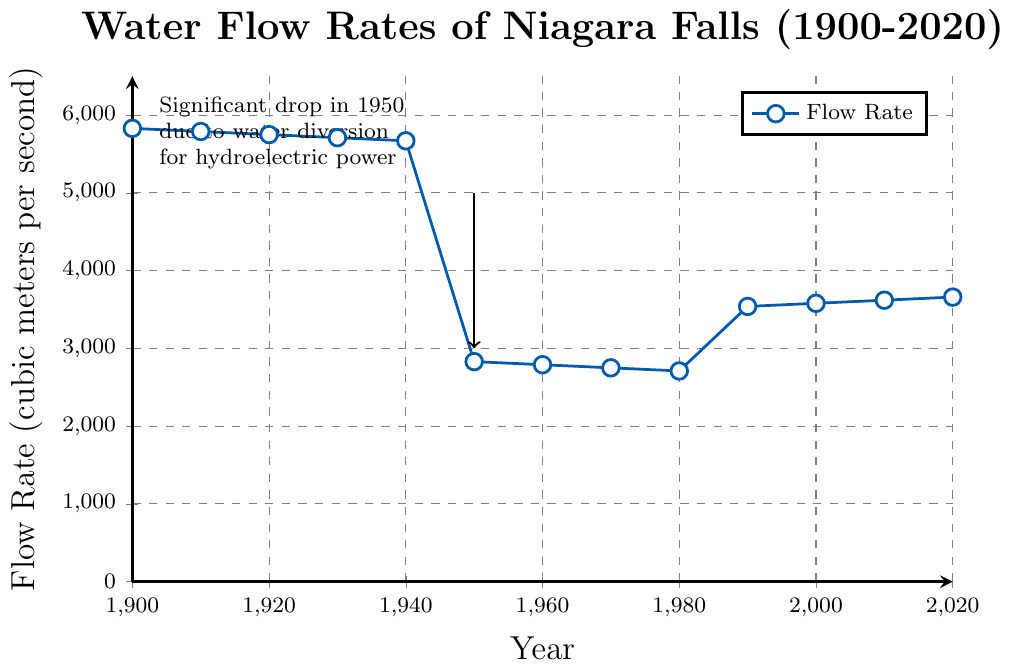What was the flow rate in 1900 and 2020? To find the flow rate in 1900 and 2020, look at the beginning and the end points on the x-axis. In 1900, the flow rate is 5830 cubic meters per second, and in 2020, it is 3660 cubic meters per second.
Answer: 5830 and 3660 cubic meters per second Through which decades did the flow rate show a continuous decrease before starting to increase again? Observe the trend line from the early 1900s to the 1990s. The flow rate continuously decreased from the 1900s to the 1980s and then started to increase again from the 1990s onwards.
Answer: 1900s to 1980s How many times did the flow rate significantly increase? Analyze the plot for noticeable increases. There is a significant increase observed between the 1980s and the 1990s.
Answer: Once What is the difference in flow rates between 1940 and 1950? Check the flow rate in 1940 and 1950. The values are 5670 and 2830 cubic meters per second, respectively. The difference is 5670 - 2830 = 2840 cubic meters per second.
Answer: 2840 cubic meters per second During which decade was the flow rate at its lowest? Compare the flow rates across all decades. The lowest flow rate is around 1970, with a value of 2750 cubic meters per second.
Answer: 1970s What is the average flow rate from 1900 to 1940? Calculate the average by summing the flow rates from 1900 to 1940 and dividing by the number of data points: (5830 + 5790 + 5750 + 5710 + 5670) / 5 = 5750 cubic meters per second.
Answer: 5750 cubic meters per second Compare the flow rates between the peak value and the lowest value, and state the years they occurred. Identify the peak and lowest values on the chart. The peak flow rate is 5830 cubic meters per second in 1900 and the lowest is 2710 cubic meters per second in 1980.
Answer: 1900 (5830) and 1980 (2710) Explain the notable drop in the flow rate around 1950. The figure includes an annotation pointing out a significant drop around 1950 due to water diversion for hydroelectric power. This explains the drop from about 5670 to 2830 cubic meters per second.
Answer: Due to water diversion for hydroelectric power 